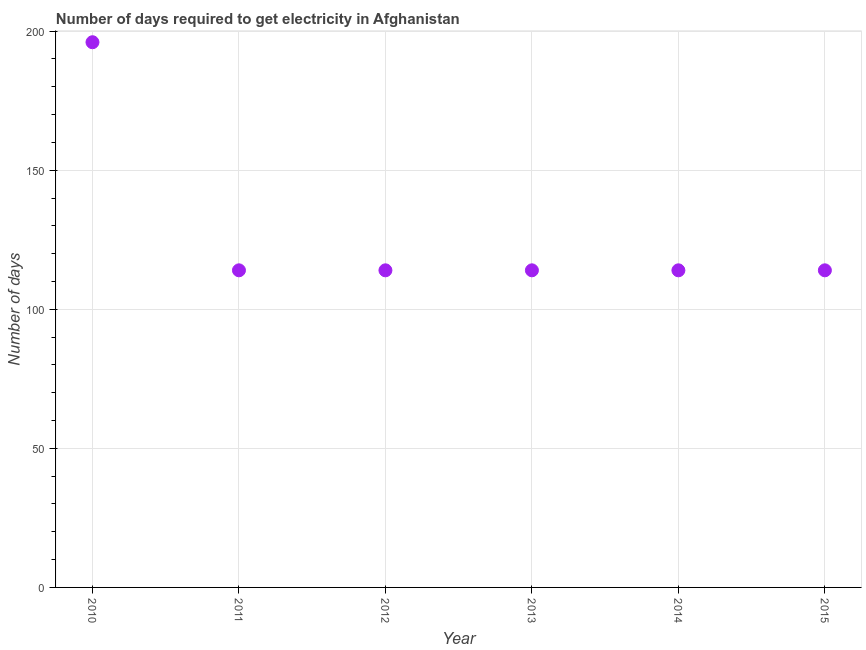What is the time to get electricity in 2014?
Provide a short and direct response. 114. Across all years, what is the maximum time to get electricity?
Keep it short and to the point. 196. Across all years, what is the minimum time to get electricity?
Your answer should be compact. 114. In which year was the time to get electricity maximum?
Your answer should be compact. 2010. In which year was the time to get electricity minimum?
Give a very brief answer. 2011. What is the sum of the time to get electricity?
Offer a terse response. 766. What is the difference between the time to get electricity in 2013 and 2014?
Offer a very short reply. 0. What is the average time to get electricity per year?
Give a very brief answer. 127.67. What is the median time to get electricity?
Your response must be concise. 114. In how many years, is the time to get electricity greater than 130 ?
Ensure brevity in your answer.  1. What is the ratio of the time to get electricity in 2011 to that in 2012?
Make the answer very short. 1. Is the time to get electricity in 2010 less than that in 2015?
Make the answer very short. No. Is the difference between the time to get electricity in 2010 and 2013 greater than the difference between any two years?
Offer a very short reply. Yes. What is the difference between the highest and the lowest time to get electricity?
Make the answer very short. 82. In how many years, is the time to get electricity greater than the average time to get electricity taken over all years?
Offer a terse response. 1. How many years are there in the graph?
Your response must be concise. 6. Are the values on the major ticks of Y-axis written in scientific E-notation?
Your answer should be compact. No. Does the graph contain grids?
Provide a succinct answer. Yes. What is the title of the graph?
Make the answer very short. Number of days required to get electricity in Afghanistan. What is the label or title of the X-axis?
Provide a short and direct response. Year. What is the label or title of the Y-axis?
Provide a short and direct response. Number of days. What is the Number of days in 2010?
Keep it short and to the point. 196. What is the Number of days in 2011?
Keep it short and to the point. 114. What is the Number of days in 2012?
Give a very brief answer. 114. What is the Number of days in 2013?
Provide a succinct answer. 114. What is the Number of days in 2014?
Your answer should be very brief. 114. What is the Number of days in 2015?
Keep it short and to the point. 114. What is the difference between the Number of days in 2010 and 2012?
Ensure brevity in your answer.  82. What is the difference between the Number of days in 2010 and 2013?
Make the answer very short. 82. What is the difference between the Number of days in 2010 and 2015?
Provide a succinct answer. 82. What is the difference between the Number of days in 2011 and 2013?
Give a very brief answer. 0. What is the difference between the Number of days in 2012 and 2013?
Offer a very short reply. 0. What is the difference between the Number of days in 2013 and 2015?
Give a very brief answer. 0. What is the ratio of the Number of days in 2010 to that in 2011?
Offer a very short reply. 1.72. What is the ratio of the Number of days in 2010 to that in 2012?
Provide a short and direct response. 1.72. What is the ratio of the Number of days in 2010 to that in 2013?
Your answer should be compact. 1.72. What is the ratio of the Number of days in 2010 to that in 2014?
Keep it short and to the point. 1.72. What is the ratio of the Number of days in 2010 to that in 2015?
Ensure brevity in your answer.  1.72. What is the ratio of the Number of days in 2011 to that in 2012?
Provide a succinct answer. 1. What is the ratio of the Number of days in 2011 to that in 2015?
Offer a terse response. 1. What is the ratio of the Number of days in 2012 to that in 2013?
Offer a very short reply. 1. What is the ratio of the Number of days in 2013 to that in 2014?
Your answer should be very brief. 1. What is the ratio of the Number of days in 2013 to that in 2015?
Your answer should be compact. 1. 